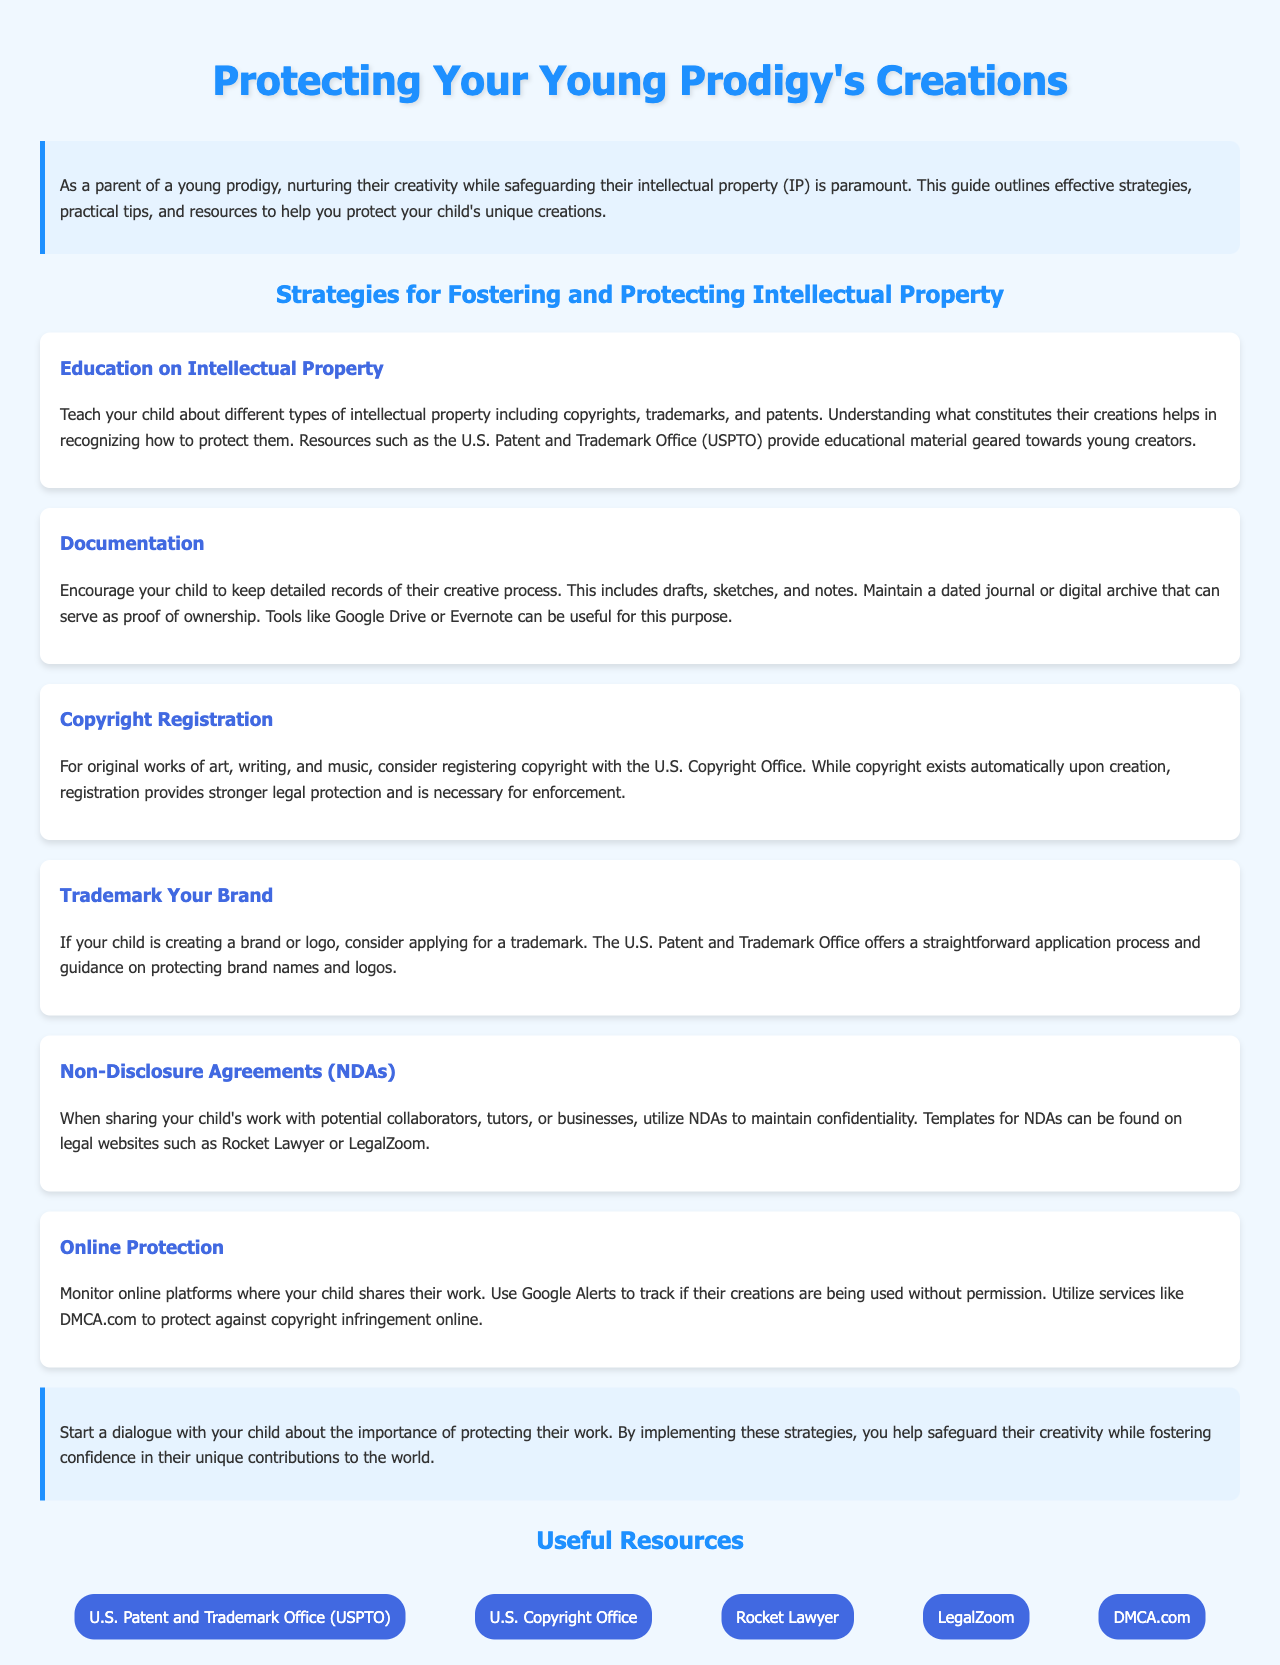What is the title of the document? The title is mentioned at the top of the document, which gives a clear indication of its purpose.
Answer: Protecting Your Young Prodigy's Creations What is one of the suggested strategies for protecting intellectual property? The strategies listed in the document provide ways to legally safeguard creations.
Answer: Education on Intellectual Property What organization offers resources for copyright registration? The document specifies governmental resources related to intellectual property protection, including copyright.
Answer: U.S. Copyright Office What tool can be used to monitor online use of creations? The document suggests practical tools for parents to keep track of their child's work online.
Answer: Google Alerts What type of agreement should be used when sharing work with collaborators? The document mentions a specific agreement type designed to maintain confidentiality when proving work to others.
Answer: Non-Disclosure Agreements (NDAs) Which resource can assist with legal documentation? The document lists several resources, including websites that provide legal documents and services.
Answer: Rocket Lawyer How should parents initiate the conversation about IP protection? The document provides advice on how to engage with children regarding their creative works and the importance of safeguarding them.
Answer: Start a dialogue What is the main concern for parents of young creators mentioned in the document? The document highlights the overarching responsibility of parents regarding the creations of their prodigious children.
Answer: Safeguarding their intellectual property 